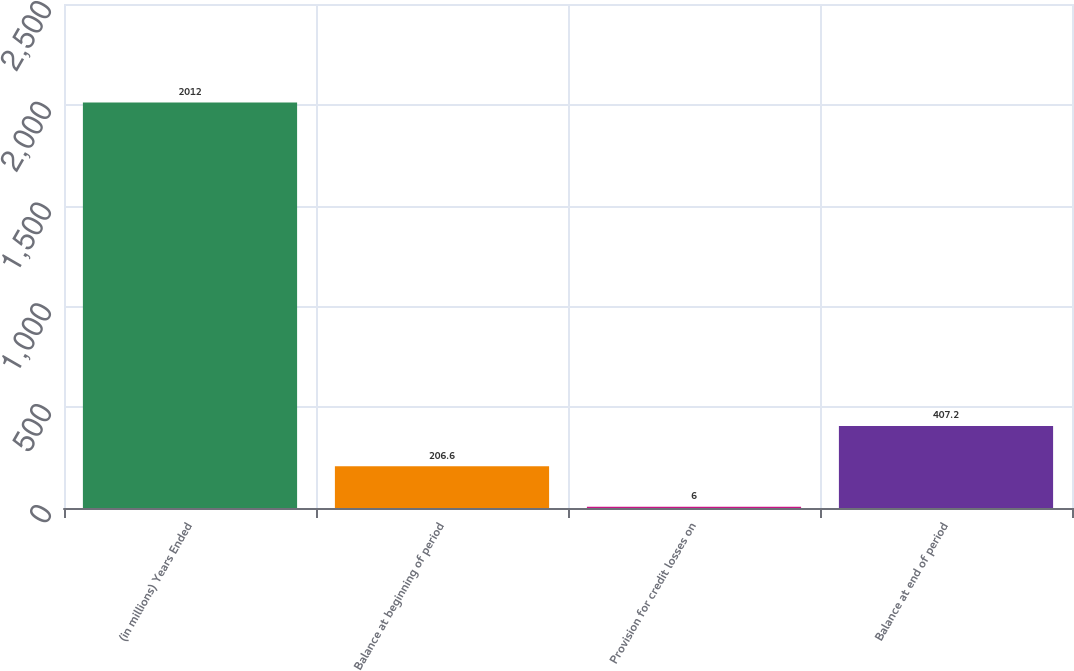<chart> <loc_0><loc_0><loc_500><loc_500><bar_chart><fcel>(in millions) Years Ended<fcel>Balance at beginning of period<fcel>Provision for credit losses on<fcel>Balance at end of period<nl><fcel>2012<fcel>206.6<fcel>6<fcel>407.2<nl></chart> 